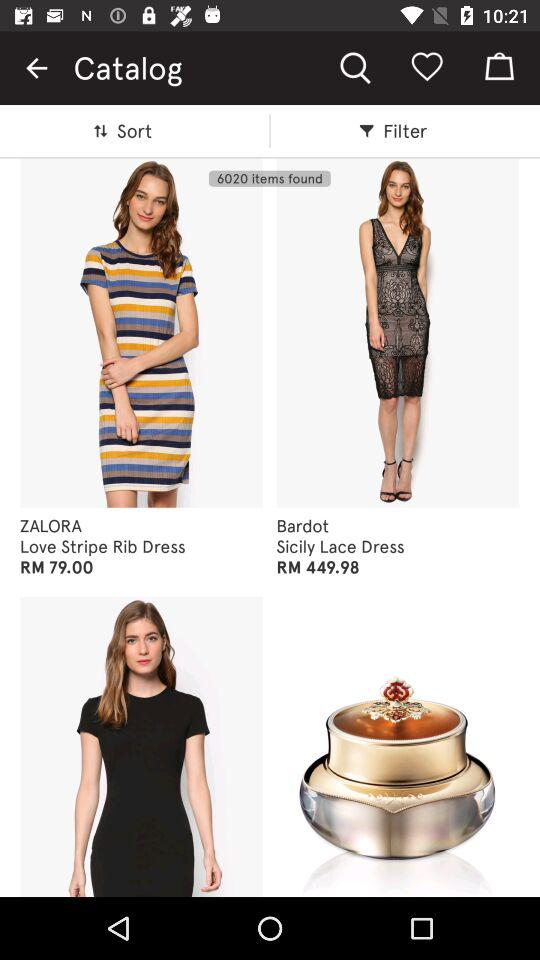How much more expensive is the Sicily Lace Dress than the Love Stripe Rib Dress?
Answer the question using a single word or phrase. RM 370.98 